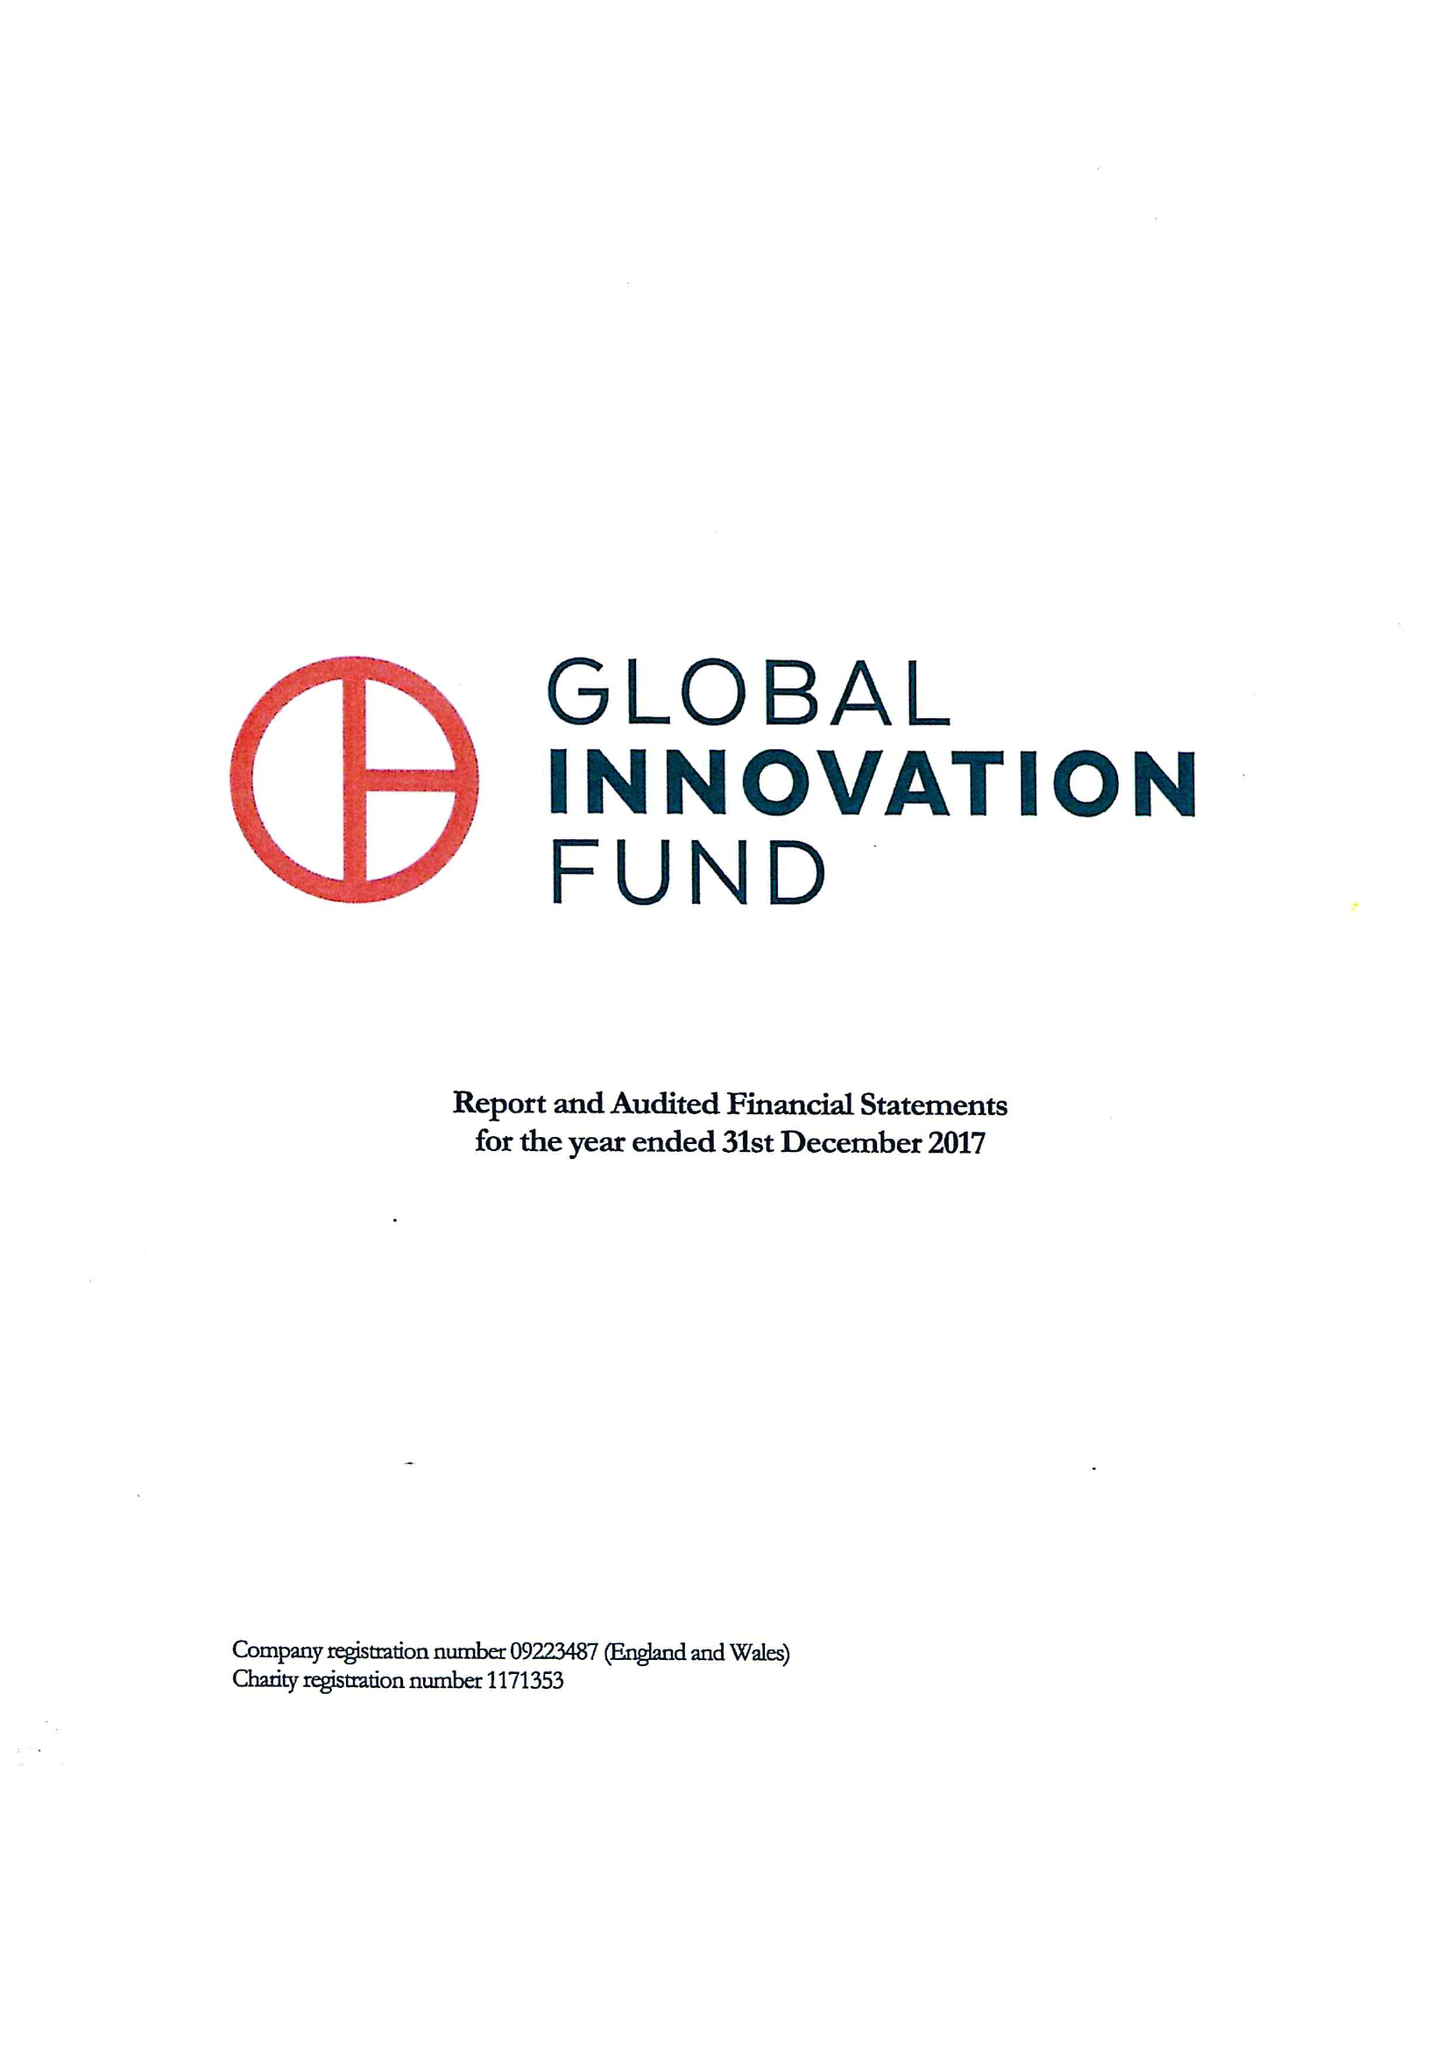What is the value for the address__postcode?
Answer the question using a single word or phrase. E1 5JL 